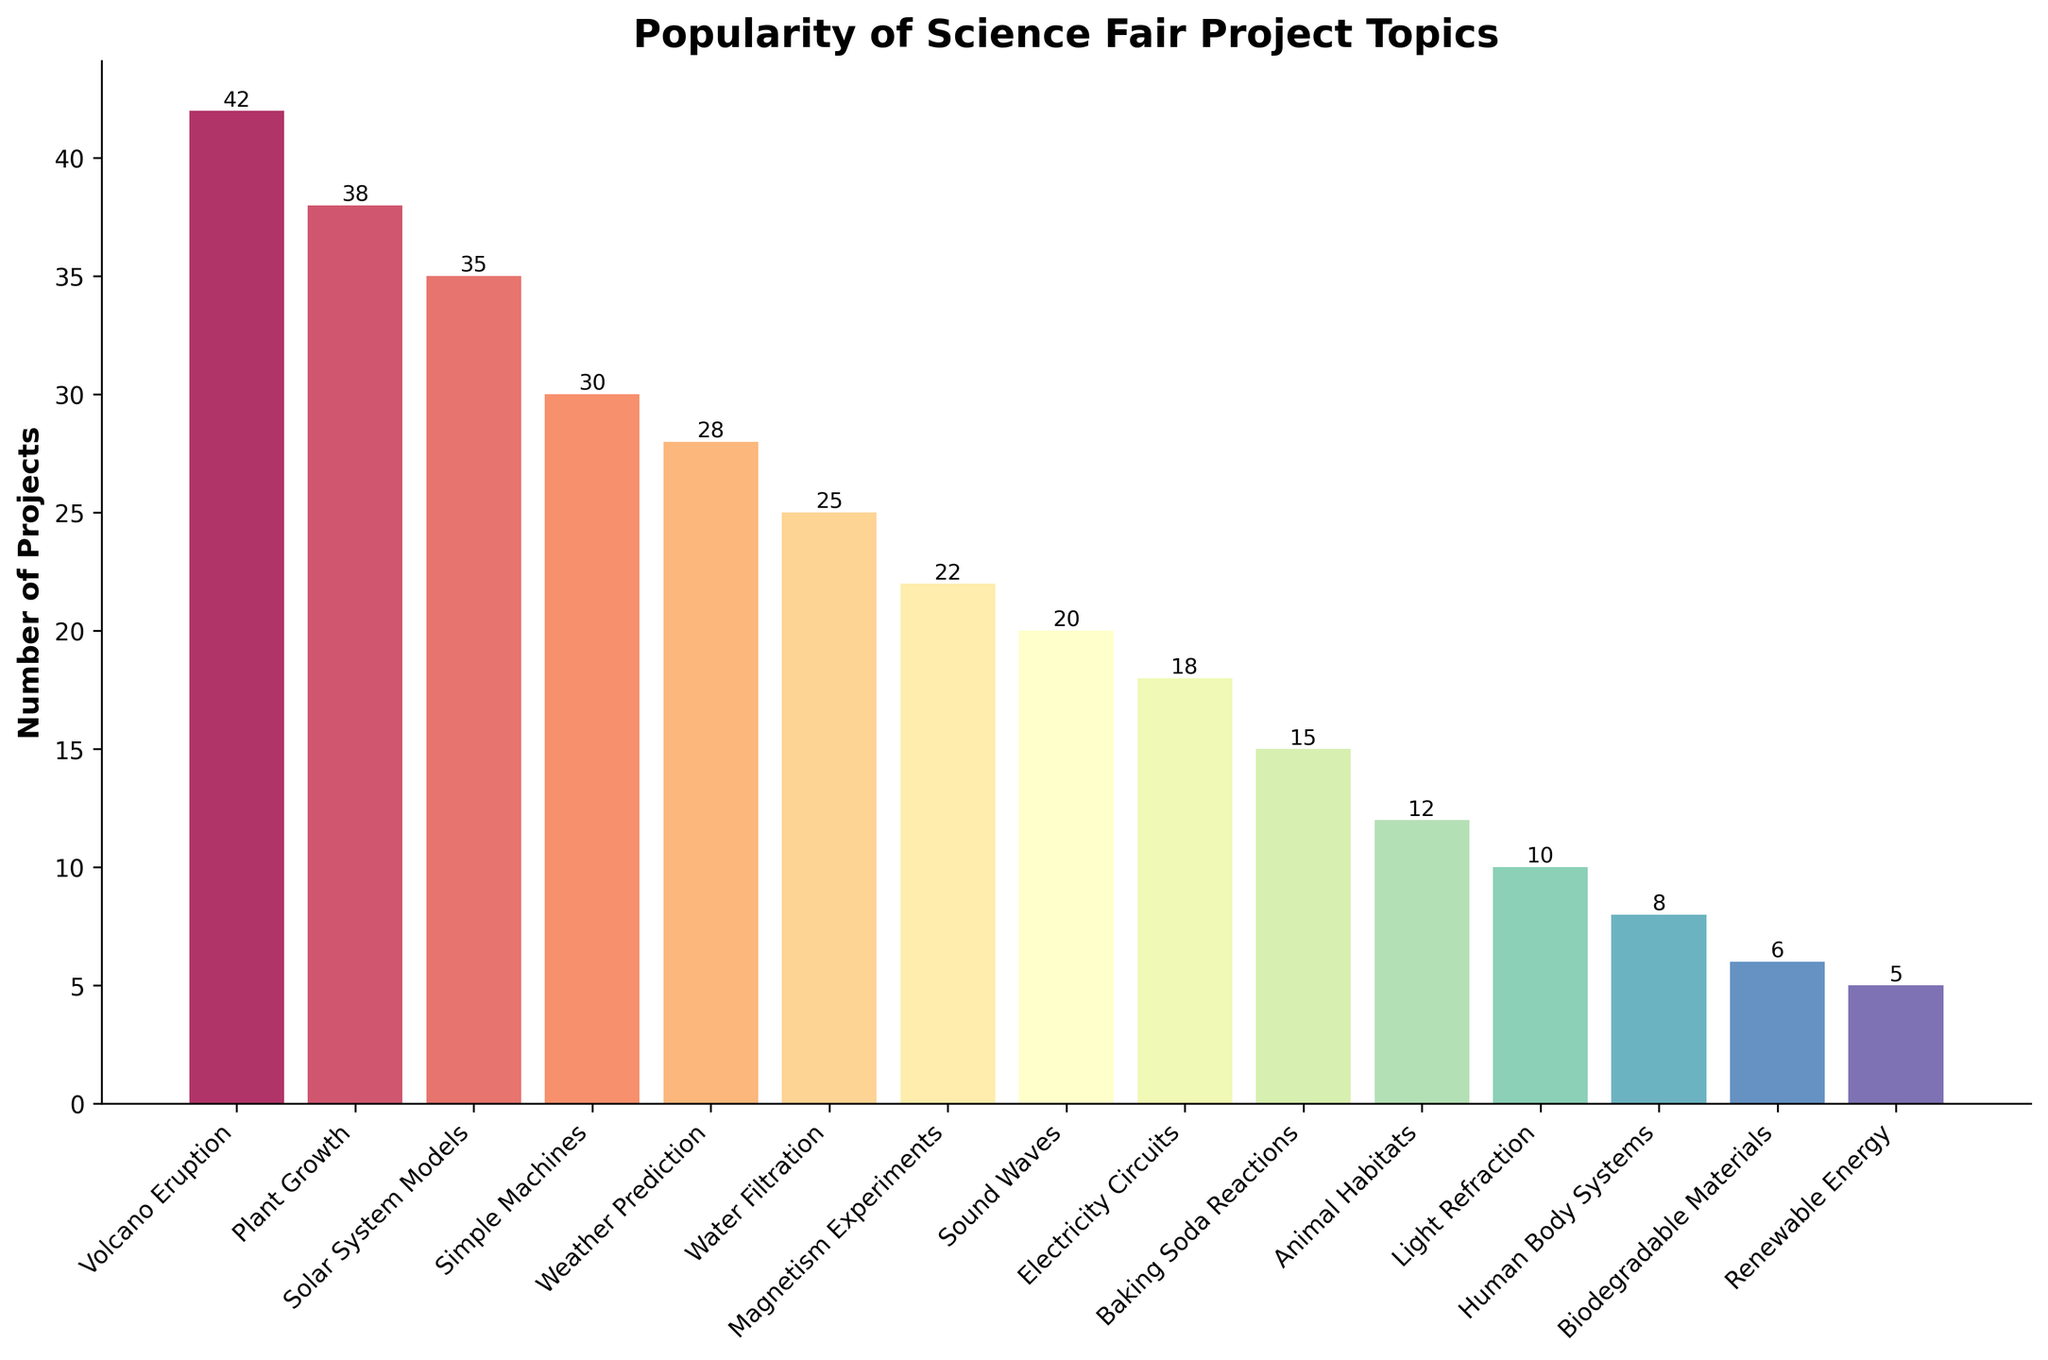Which science fair project topic is the most popular? The number of projects for each topic is shown in the bars. The tallest bar represents "Volcano Eruption," which has the highest number of projects.
Answer: Volcano Eruption How many more projects does the most popular topic have compared to the second most popular topic? "Volcano Eruption" has 42 projects and "Plant Growth" has 38. The difference is 42 - 38.
Answer: 4 What is the average number of projects for the top three topics? The top three topics are "Volcano Eruption" (42), "Plant Growth" (38), and "Solar System Models" (35). The sum is 42 + 38 + 35 = 115. The average is 115 / 3.
Answer: 38.33 Which topic has fewer projects, "Sound Waves" or "Electricity Circuits"? "Sound Waves" has 20 projects and "Electricity Circuits" has 18. The bar for "Sound Waves" is taller than the bar for "Electricity Circuits," meaning "Electricity Circuits" has fewer projects.
Answer: Electricity Circuits How many projects are there in total for "Magnetism Experiments," "Sound Waves," and "Electricity Circuits"? "Magnetism Experiments" has 22 projects, "Sound Waves" has 20, and "Electricity Circuits" has 18. Sum them up: 22 + 20 + 18.
Answer: 60 What colors are used for the bars representing "Water Filtration" and "Baking Soda Reactions"? The bar for "Water Filtration" is light green and the bar for "Baking Soda Reactions" is orange.
Answer: light green and orange Are there more projects on "Animal Habitats" or "Human Body Systems"? The bar for "Animal Habitats" is taller with 12 projects compared to the bar for "Human Body Systems" which has 8.
Answer: Animal Habitats What is the median number of projects among all topics? Ordering the number of projects: 5, 6, 8, 10, 12, 15, 18, 20, 22, 25, 28, 30, 35, 38, 42. The median is the middle value in this ordered list, which is 20 (the 8th value of 15 total values).
Answer: 20 How many topics have fewer than 20 projects? Count the bars with heights representing fewer than 20 projects: "Baking Soda Reactions" (15), "Animal Habitats" (12), "Light Refraction" (10), "Human Body Systems" (8), "Biodegradable Materials" (6), and "Renewable Energy" (5). There are 6 such topics.
Answer: 6 What's the difference between the number of projects on "Simple Machines" and "Weather Prediction"? "Simple Machines" has 30 projects and "Weather Prediction" has 28. The difference is 30 - 28.
Answer: 2 